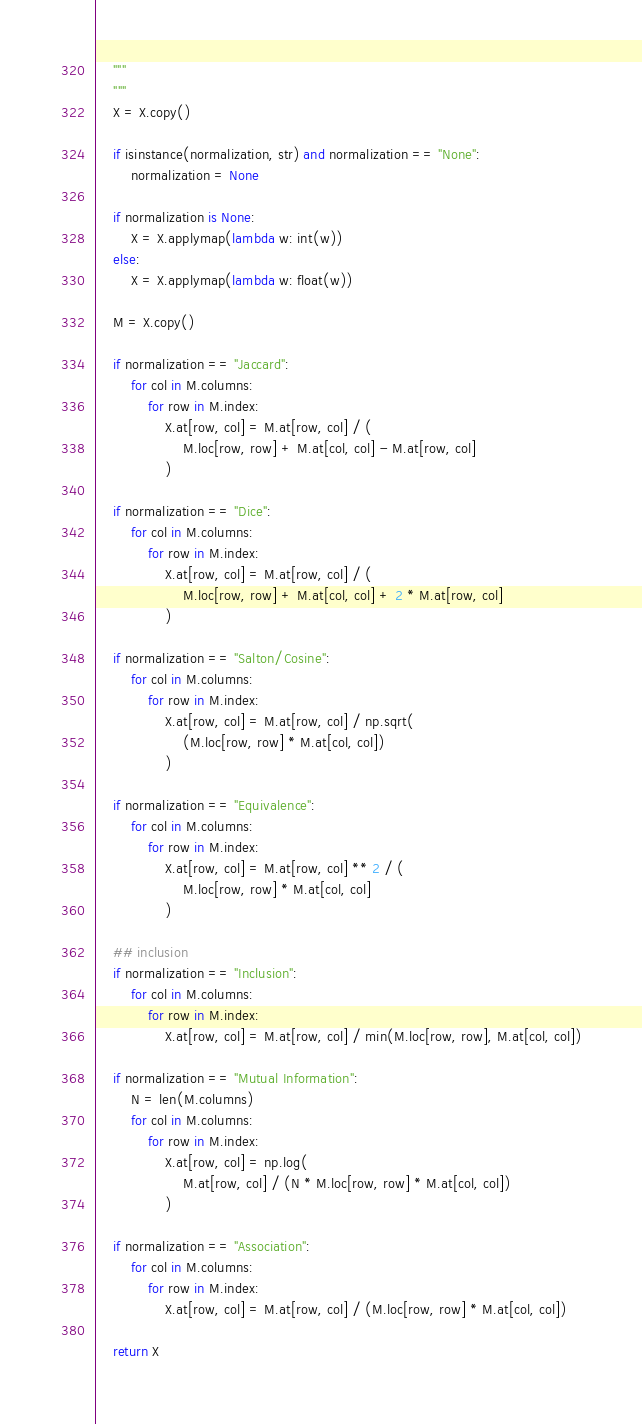Convert code to text. <code><loc_0><loc_0><loc_500><loc_500><_Python_>    """
    """
    X = X.copy()

    if isinstance(normalization, str) and normalization == "None":
        normalization = None

    if normalization is None:
        X = X.applymap(lambda w: int(w))
    else:
        X = X.applymap(lambda w: float(w))

    M = X.copy()

    if normalization == "Jaccard":
        for col in M.columns:
            for row in M.index:
                X.at[row, col] = M.at[row, col] / (
                    M.loc[row, row] + M.at[col, col] - M.at[row, col]
                )

    if normalization == "Dice":
        for col in M.columns:
            for row in M.index:
                X.at[row, col] = M.at[row, col] / (
                    M.loc[row, row] + M.at[col, col] + 2 * M.at[row, col]
                )

    if normalization == "Salton/Cosine":
        for col in M.columns:
            for row in M.index:
                X.at[row, col] = M.at[row, col] / np.sqrt(
                    (M.loc[row, row] * M.at[col, col])
                )

    if normalization == "Equivalence":
        for col in M.columns:
            for row in M.index:
                X.at[row, col] = M.at[row, col] ** 2 / (
                    M.loc[row, row] * M.at[col, col]
                )

    ## inclusion
    if normalization == "Inclusion":
        for col in M.columns:
            for row in M.index:
                X.at[row, col] = M.at[row, col] / min(M.loc[row, row], M.at[col, col])

    if normalization == "Mutual Information":
        N = len(M.columns)
        for col in M.columns:
            for row in M.index:
                X.at[row, col] = np.log(
                    M.at[row, col] / (N * M.loc[row, row] * M.at[col, col])
                )

    if normalization == "Association":
        for col in M.columns:
            for row in M.index:
                X.at[row, col] = M.at[row, col] / (M.loc[row, row] * M.at[col, col])

    return X
</code> 